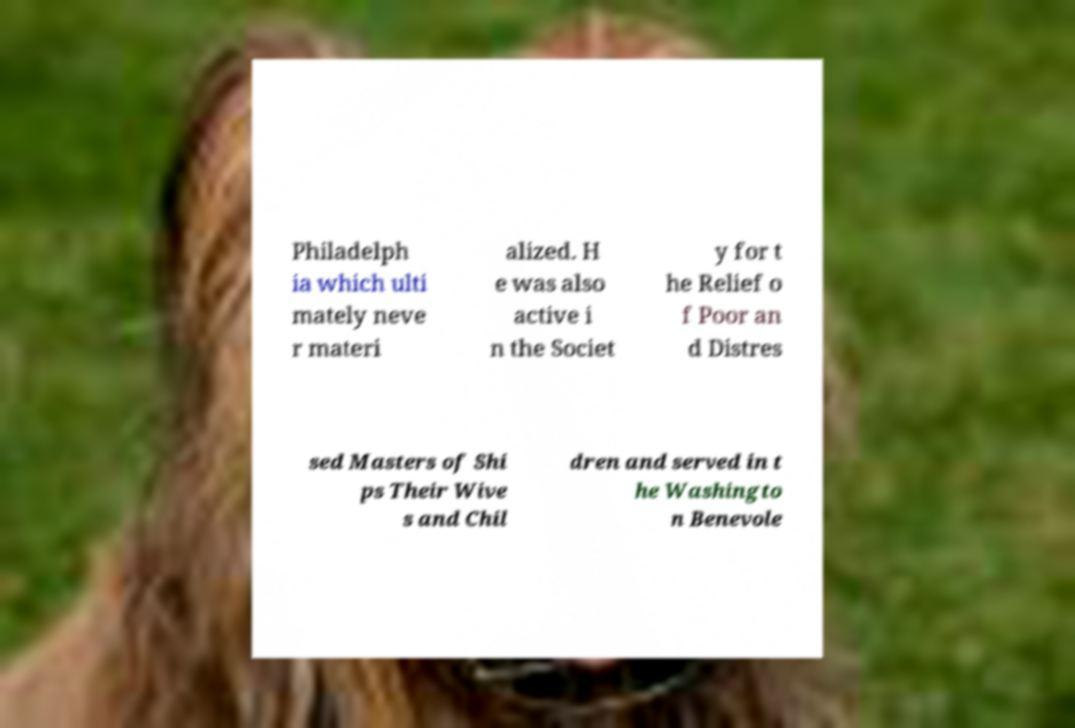Can you read and provide the text displayed in the image?This photo seems to have some interesting text. Can you extract and type it out for me? Philadelph ia which ulti mately neve r materi alized. H e was also active i n the Societ y for t he Relief o f Poor an d Distres sed Masters of Shi ps Their Wive s and Chil dren and served in t he Washingto n Benevole 